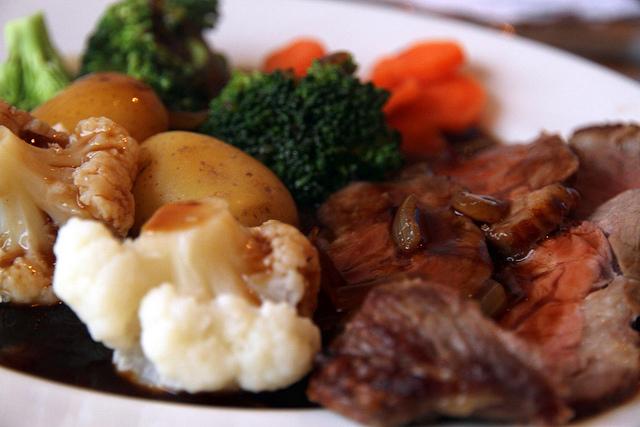What on the plate is calciferous?
Short answer required. Cauliflower. What is the green vegetable?
Be succinct. Broccoli. What are the white vegetables?
Keep it brief. Cauliflower. 